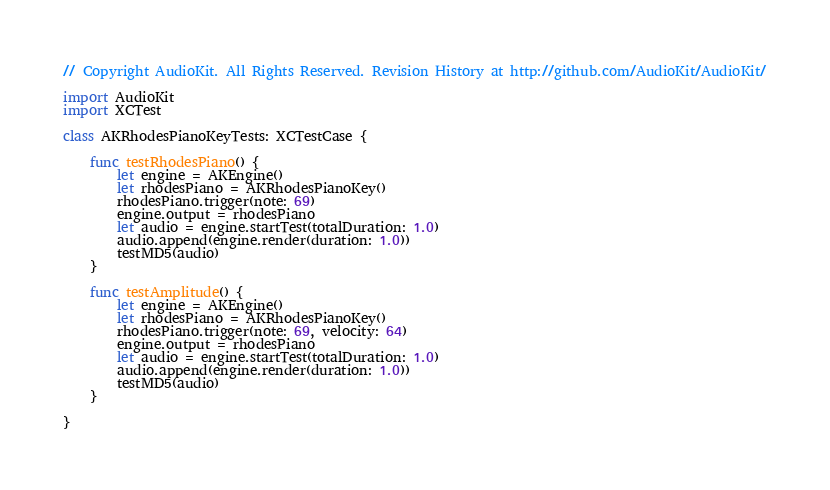Convert code to text. <code><loc_0><loc_0><loc_500><loc_500><_Swift_>// Copyright AudioKit. All Rights Reserved. Revision History at http://github.com/AudioKit/AudioKit/

import AudioKit
import XCTest

class AKRhodesPianoKeyTests: XCTestCase {

    func testRhodesPiano() {
        let engine = AKEngine()
        let rhodesPiano = AKRhodesPianoKey()
        rhodesPiano.trigger(note: 69)
        engine.output = rhodesPiano
        let audio = engine.startTest(totalDuration: 1.0)
        audio.append(engine.render(duration: 1.0))
        testMD5(audio)
    }

    func testAmplitude() {
        let engine = AKEngine()
        let rhodesPiano = AKRhodesPianoKey()
        rhodesPiano.trigger(note: 69, velocity: 64)
        engine.output = rhodesPiano
        let audio = engine.startTest(totalDuration: 1.0)
        audio.append(engine.render(duration: 1.0))
        testMD5(audio)
    }

}
</code> 